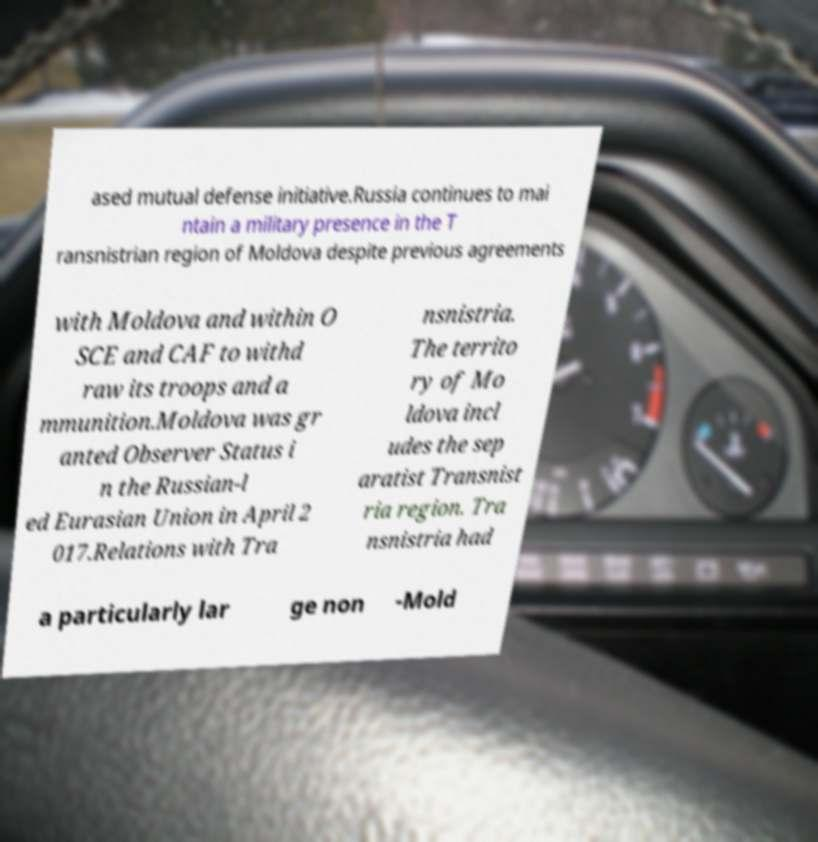Can you accurately transcribe the text from the provided image for me? ased mutual defense initiative.Russia continues to mai ntain a military presence in the T ransnistrian region of Moldova despite previous agreements with Moldova and within O SCE and CAF to withd raw its troops and a mmunition.Moldova was gr anted Observer Status i n the Russian-l ed Eurasian Union in April 2 017.Relations with Tra nsnistria. The territo ry of Mo ldova incl udes the sep aratist Transnist ria region. Tra nsnistria had a particularly lar ge non -Mold 